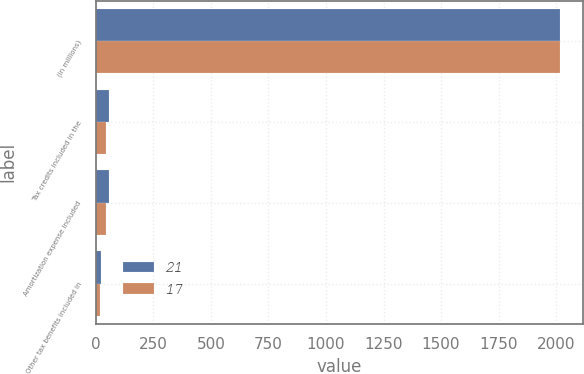Convert chart to OTSL. <chart><loc_0><loc_0><loc_500><loc_500><stacked_bar_chart><ecel><fcel>(in millions)<fcel>Tax credits included in the<fcel>Amortization expense included<fcel>Other tax benefits included in<nl><fcel>21<fcel>2016<fcel>59<fcel>59<fcel>21<nl><fcel>17<fcel>2015<fcel>45<fcel>45<fcel>17<nl></chart> 